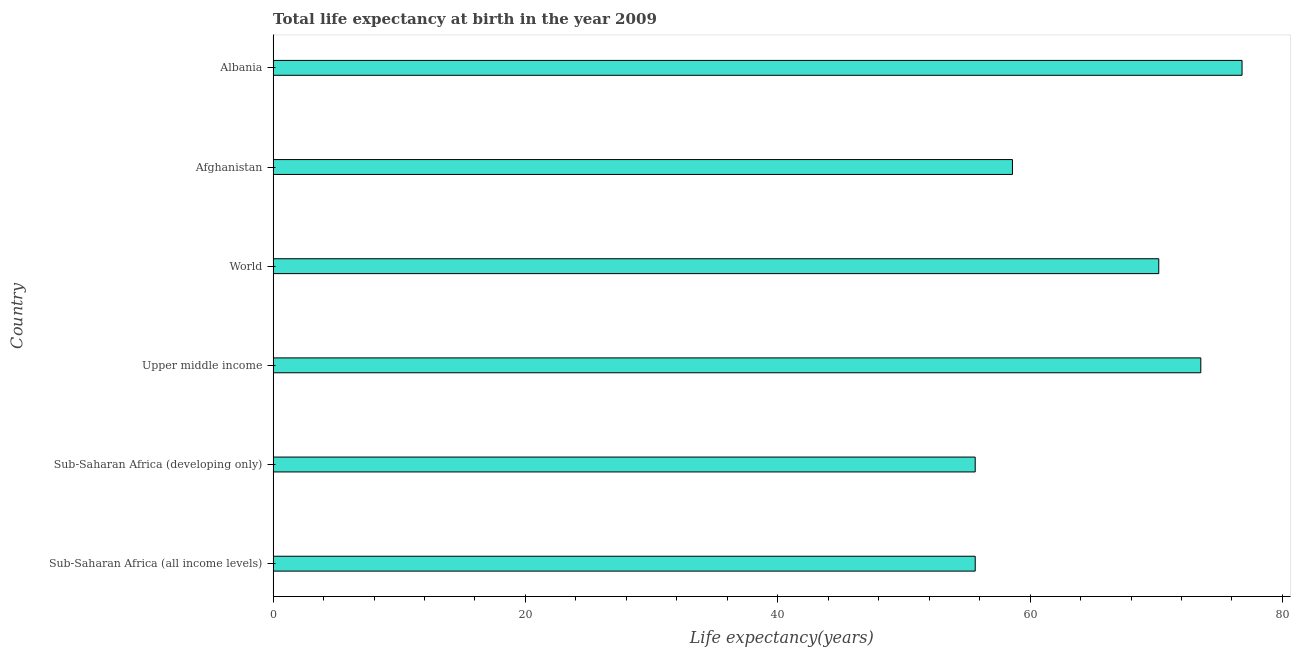Does the graph contain any zero values?
Your answer should be very brief. No. What is the title of the graph?
Give a very brief answer. Total life expectancy at birth in the year 2009. What is the label or title of the X-axis?
Provide a succinct answer. Life expectancy(years). What is the label or title of the Y-axis?
Give a very brief answer. Country. What is the life expectancy at birth in Albania?
Provide a succinct answer. 76.8. Across all countries, what is the maximum life expectancy at birth?
Give a very brief answer. 76.8. Across all countries, what is the minimum life expectancy at birth?
Your answer should be compact. 55.65. In which country was the life expectancy at birth maximum?
Your response must be concise. Albania. In which country was the life expectancy at birth minimum?
Give a very brief answer. Sub-Saharan Africa (developing only). What is the sum of the life expectancy at birth?
Give a very brief answer. 390.44. What is the difference between the life expectancy at birth in Afghanistan and Albania?
Your answer should be very brief. -18.2. What is the average life expectancy at birth per country?
Ensure brevity in your answer.  65.07. What is the median life expectancy at birth?
Make the answer very short. 64.4. In how many countries, is the life expectancy at birth greater than 60 years?
Offer a terse response. 3. Is the difference between the life expectancy at birth in Sub-Saharan Africa (all income levels) and World greater than the difference between any two countries?
Give a very brief answer. No. What is the difference between the highest and the second highest life expectancy at birth?
Offer a very short reply. 3.27. What is the difference between the highest and the lowest life expectancy at birth?
Ensure brevity in your answer.  21.15. How many bars are there?
Your response must be concise. 6. Are all the bars in the graph horizontal?
Make the answer very short. Yes. What is the difference between two consecutive major ticks on the X-axis?
Provide a short and direct response. 20. What is the Life expectancy(years) of Sub-Saharan Africa (all income levels)?
Give a very brief answer. 55.65. What is the Life expectancy(years) of Sub-Saharan Africa (developing only)?
Keep it short and to the point. 55.65. What is the Life expectancy(years) in Upper middle income?
Offer a terse response. 73.53. What is the Life expectancy(years) in World?
Give a very brief answer. 70.2. What is the Life expectancy(years) in Afghanistan?
Give a very brief answer. 58.6. What is the Life expectancy(years) of Albania?
Give a very brief answer. 76.8. What is the difference between the Life expectancy(years) in Sub-Saharan Africa (all income levels) and Sub-Saharan Africa (developing only)?
Your response must be concise. 0. What is the difference between the Life expectancy(years) in Sub-Saharan Africa (all income levels) and Upper middle income?
Give a very brief answer. -17.88. What is the difference between the Life expectancy(years) in Sub-Saharan Africa (all income levels) and World?
Ensure brevity in your answer.  -14.55. What is the difference between the Life expectancy(years) in Sub-Saharan Africa (all income levels) and Afghanistan?
Give a very brief answer. -2.95. What is the difference between the Life expectancy(years) in Sub-Saharan Africa (all income levels) and Albania?
Offer a very short reply. -21.15. What is the difference between the Life expectancy(years) in Sub-Saharan Africa (developing only) and Upper middle income?
Give a very brief answer. -17.88. What is the difference between the Life expectancy(years) in Sub-Saharan Africa (developing only) and World?
Your answer should be compact. -14.55. What is the difference between the Life expectancy(years) in Sub-Saharan Africa (developing only) and Afghanistan?
Offer a terse response. -2.95. What is the difference between the Life expectancy(years) in Sub-Saharan Africa (developing only) and Albania?
Offer a very short reply. -21.15. What is the difference between the Life expectancy(years) in Upper middle income and World?
Your answer should be compact. 3.33. What is the difference between the Life expectancy(years) in Upper middle income and Afghanistan?
Offer a very short reply. 14.93. What is the difference between the Life expectancy(years) in Upper middle income and Albania?
Offer a very short reply. -3.27. What is the difference between the Life expectancy(years) in World and Afghanistan?
Offer a very short reply. 11.6. What is the difference between the Life expectancy(years) in World and Albania?
Your response must be concise. -6.6. What is the difference between the Life expectancy(years) in Afghanistan and Albania?
Offer a very short reply. -18.2. What is the ratio of the Life expectancy(years) in Sub-Saharan Africa (all income levels) to that in Upper middle income?
Your answer should be very brief. 0.76. What is the ratio of the Life expectancy(years) in Sub-Saharan Africa (all income levels) to that in World?
Your answer should be very brief. 0.79. What is the ratio of the Life expectancy(years) in Sub-Saharan Africa (all income levels) to that in Afghanistan?
Offer a very short reply. 0.95. What is the ratio of the Life expectancy(years) in Sub-Saharan Africa (all income levels) to that in Albania?
Ensure brevity in your answer.  0.72. What is the ratio of the Life expectancy(years) in Sub-Saharan Africa (developing only) to that in Upper middle income?
Make the answer very short. 0.76. What is the ratio of the Life expectancy(years) in Sub-Saharan Africa (developing only) to that in World?
Your answer should be very brief. 0.79. What is the ratio of the Life expectancy(years) in Sub-Saharan Africa (developing only) to that in Afghanistan?
Provide a short and direct response. 0.95. What is the ratio of the Life expectancy(years) in Sub-Saharan Africa (developing only) to that in Albania?
Your answer should be compact. 0.72. What is the ratio of the Life expectancy(years) in Upper middle income to that in World?
Your answer should be compact. 1.05. What is the ratio of the Life expectancy(years) in Upper middle income to that in Afghanistan?
Offer a very short reply. 1.25. What is the ratio of the Life expectancy(years) in World to that in Afghanistan?
Give a very brief answer. 1.2. What is the ratio of the Life expectancy(years) in World to that in Albania?
Ensure brevity in your answer.  0.91. What is the ratio of the Life expectancy(years) in Afghanistan to that in Albania?
Ensure brevity in your answer.  0.76. 